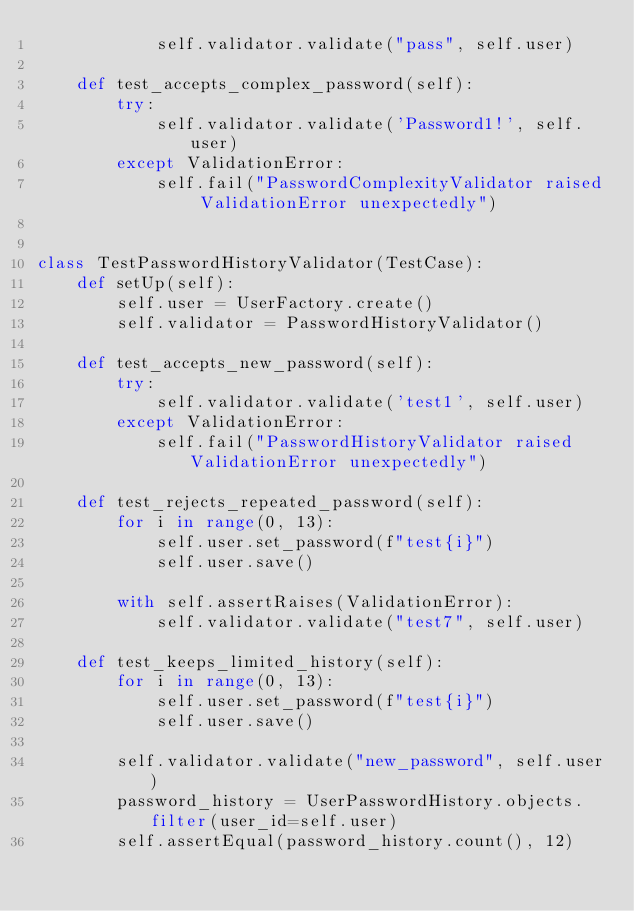<code> <loc_0><loc_0><loc_500><loc_500><_Python_>            self.validator.validate("pass", self.user)

    def test_accepts_complex_password(self):
        try:
            self.validator.validate('Password1!', self.user)
        except ValidationError:
            self.fail("PasswordComplexityValidator raised ValidationError unexpectedly")


class TestPasswordHistoryValidator(TestCase):
    def setUp(self):
        self.user = UserFactory.create()
        self.validator = PasswordHistoryValidator()

    def test_accepts_new_password(self):
        try:
            self.validator.validate('test1', self.user)
        except ValidationError:
            self.fail("PasswordHistoryValidator raised ValidationError unexpectedly")

    def test_rejects_repeated_password(self):
        for i in range(0, 13):
            self.user.set_password(f"test{i}")
            self.user.save()

        with self.assertRaises(ValidationError):
            self.validator.validate("test7", self.user)

    def test_keeps_limited_history(self):
        for i in range(0, 13):
            self.user.set_password(f"test{i}")
            self.user.save()

        self.validator.validate("new_password", self.user)
        password_history = UserPasswordHistory.objects.filter(user_id=self.user)
        self.assertEqual(password_history.count(), 12)
</code> 